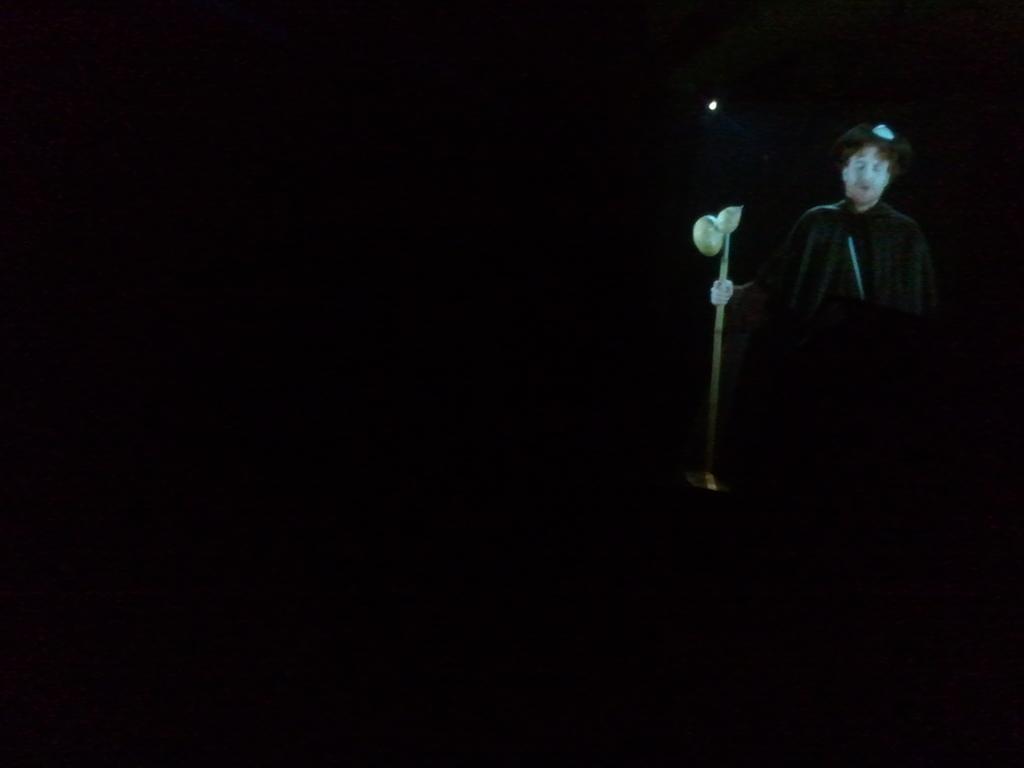Please provide a concise description of this image. It looks like an edited image. I can see a person holding a stick. There is a dark background. 